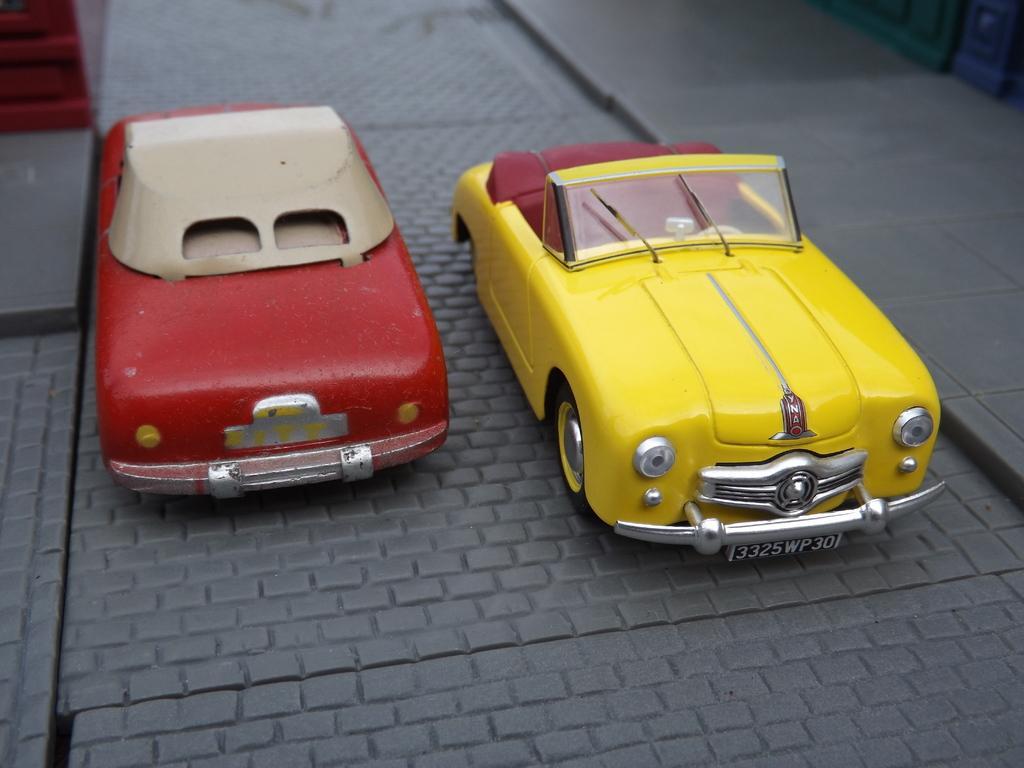Please provide a concise description of this image. In the image image we can see some toy cars. 